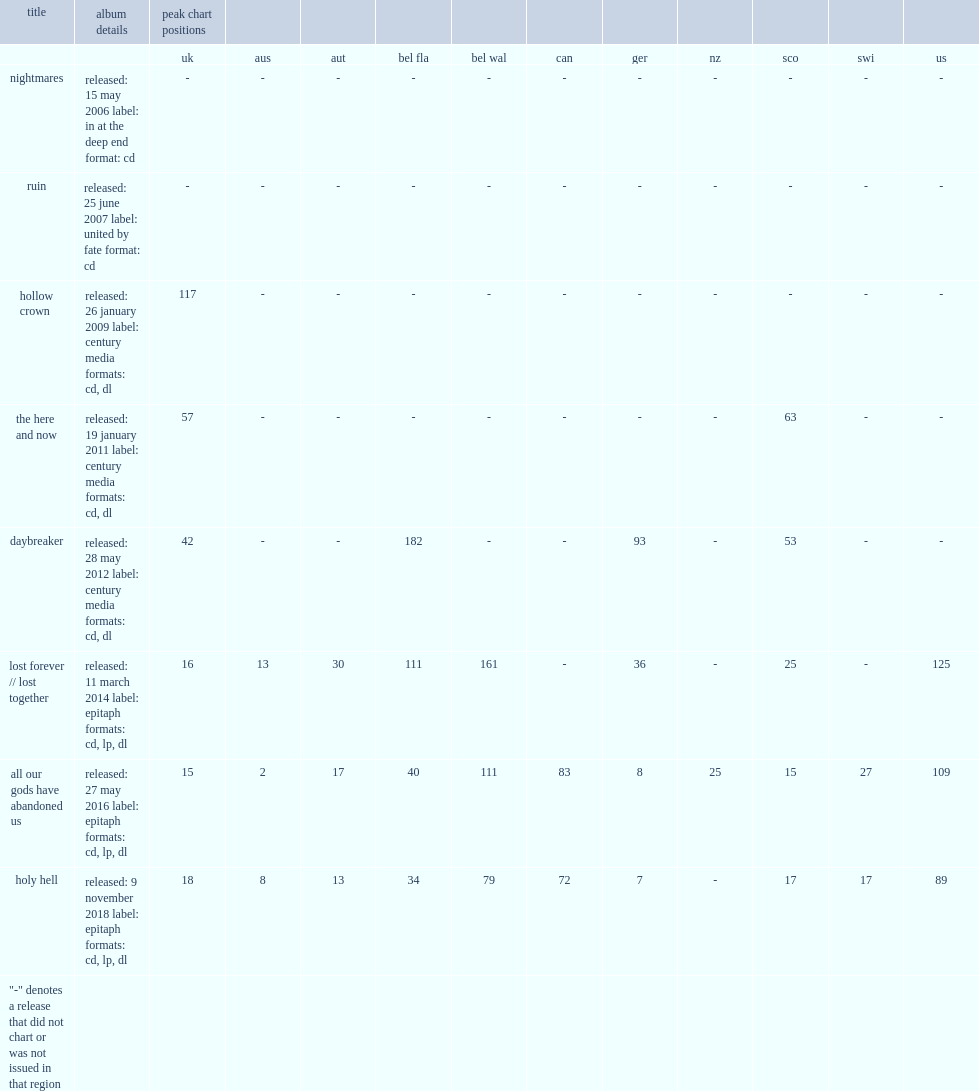What was the peak chart position on the us of lost forever // lost together ? 125.0. 